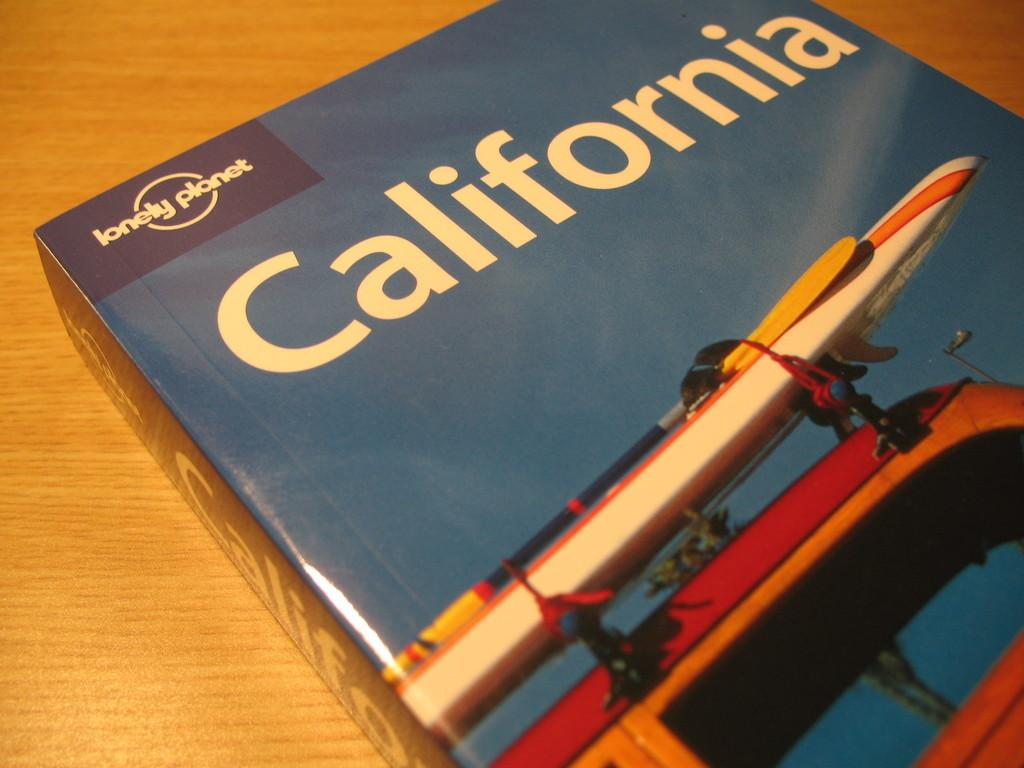<image>
Present a compact description of the photo's key features. A book, entitled California, lays on a table. 